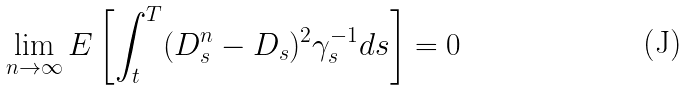Convert formula to latex. <formula><loc_0><loc_0><loc_500><loc_500>\lim _ { n \to \infty } E \left [ \int _ { t } ^ { T } ( D _ { s } ^ { n } - D _ { s } ) ^ { 2 } \gamma _ { s } ^ { - 1 } d s \right ] = 0</formula> 